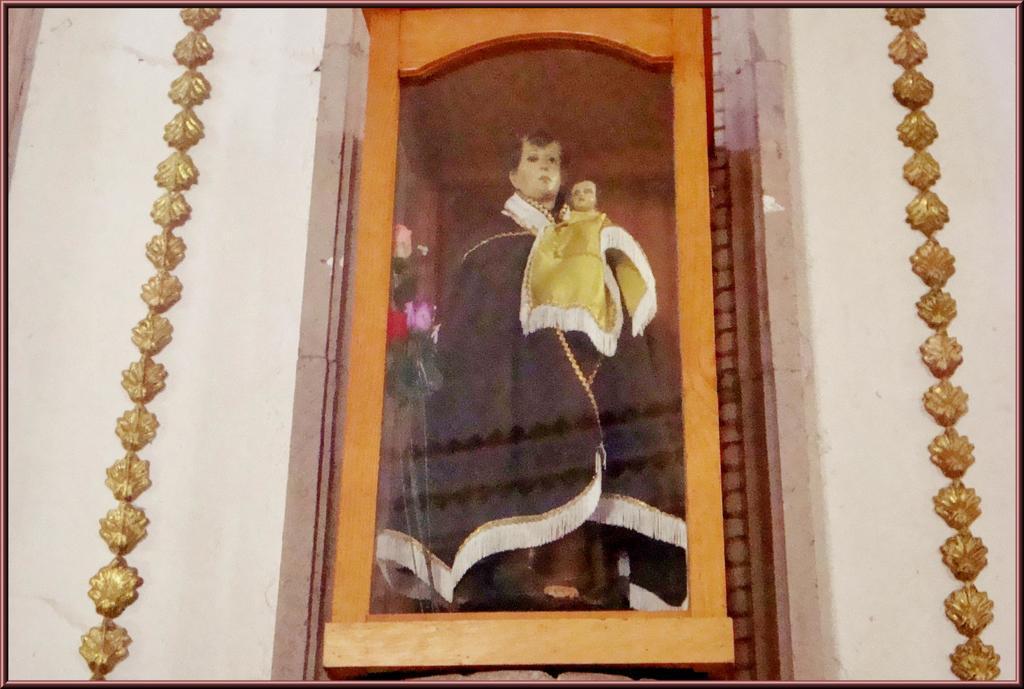Can you describe this image briefly? In this image we can see a statue of a person holding a baby in a box. We can also see a wall. 